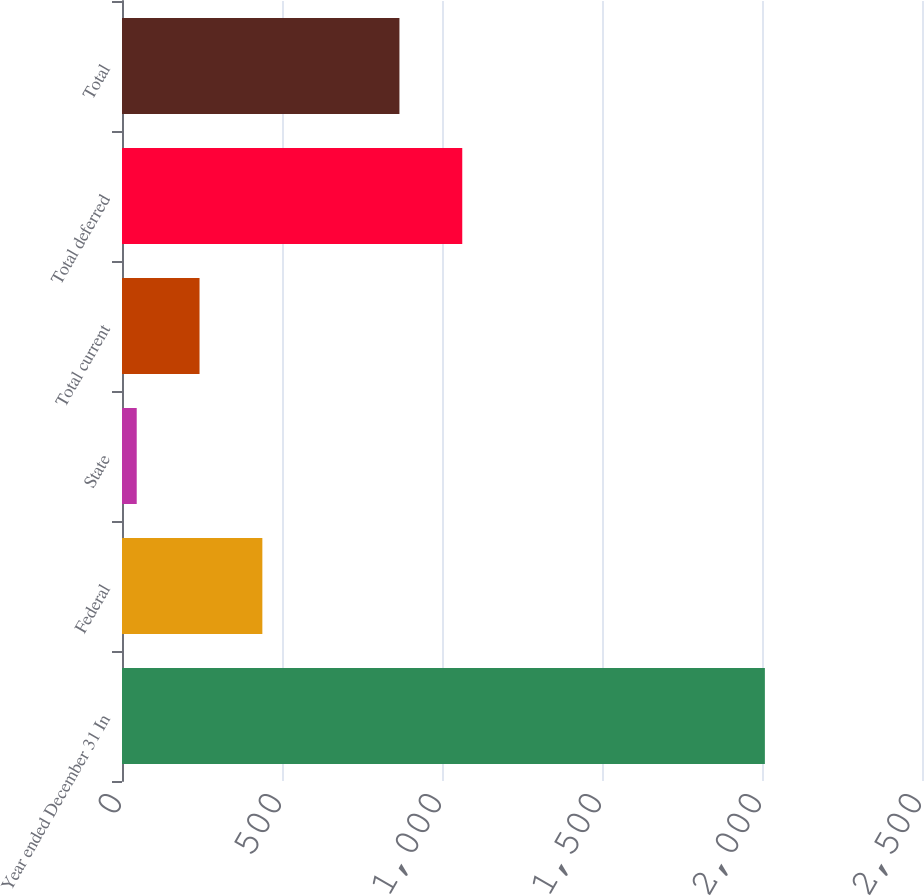Convert chart. <chart><loc_0><loc_0><loc_500><loc_500><bar_chart><fcel>Year ended December 31 In<fcel>Federal<fcel>State<fcel>Total current<fcel>Total deferred<fcel>Total<nl><fcel>2009<fcel>438.6<fcel>46<fcel>242.3<fcel>1063.3<fcel>867<nl></chart> 